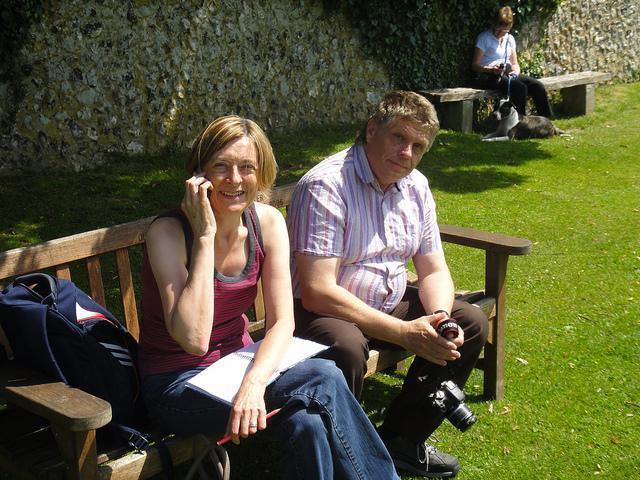What is the woman wearing sleeveless shirt doing?
Choose the right answer and clarify with the format: 'Answer: answer
Rationale: rationale.'
Options: Recording, taking photo, using phone, itching. Answer: using phone.
Rationale: Her hand is by her ear with a device in it. 